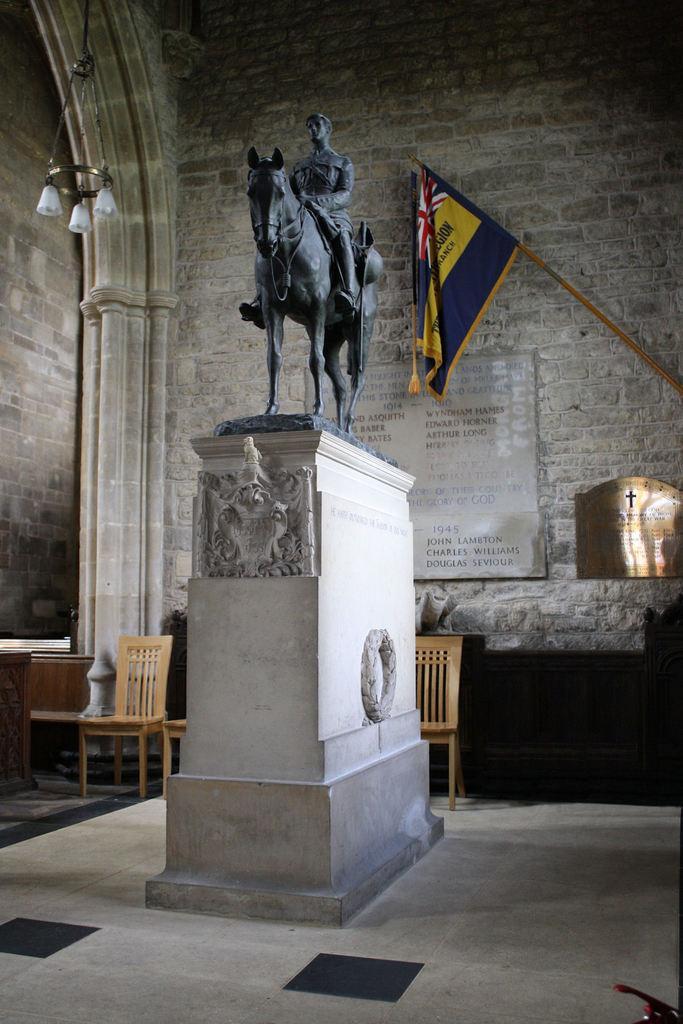Please provide a concise description of this image. In this image there is a statue, in the background there is a wall to that wall there is a flag, two shields on that shields there is some text, near to the wall there are chairs. 